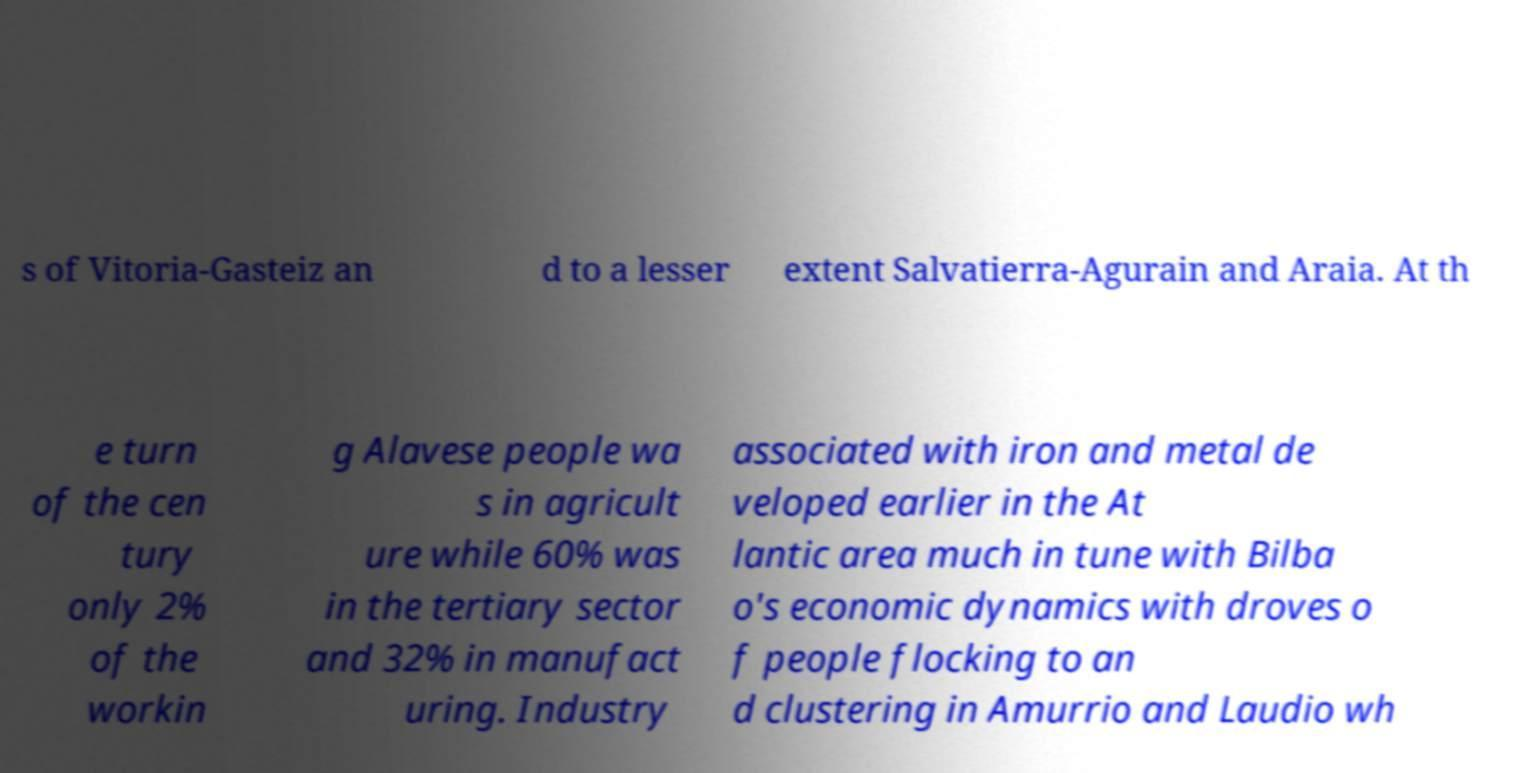There's text embedded in this image that I need extracted. Can you transcribe it verbatim? s of Vitoria-Gasteiz an d to a lesser extent Salvatierra-Agurain and Araia. At th e turn of the cen tury only 2% of the workin g Alavese people wa s in agricult ure while 60% was in the tertiary sector and 32% in manufact uring. Industry associated with iron and metal de veloped earlier in the At lantic area much in tune with Bilba o's economic dynamics with droves o f people flocking to an d clustering in Amurrio and Laudio wh 